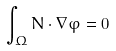<formula> <loc_0><loc_0><loc_500><loc_500>\int _ { \Omega } N \cdot \nabla \varphi = 0</formula> 